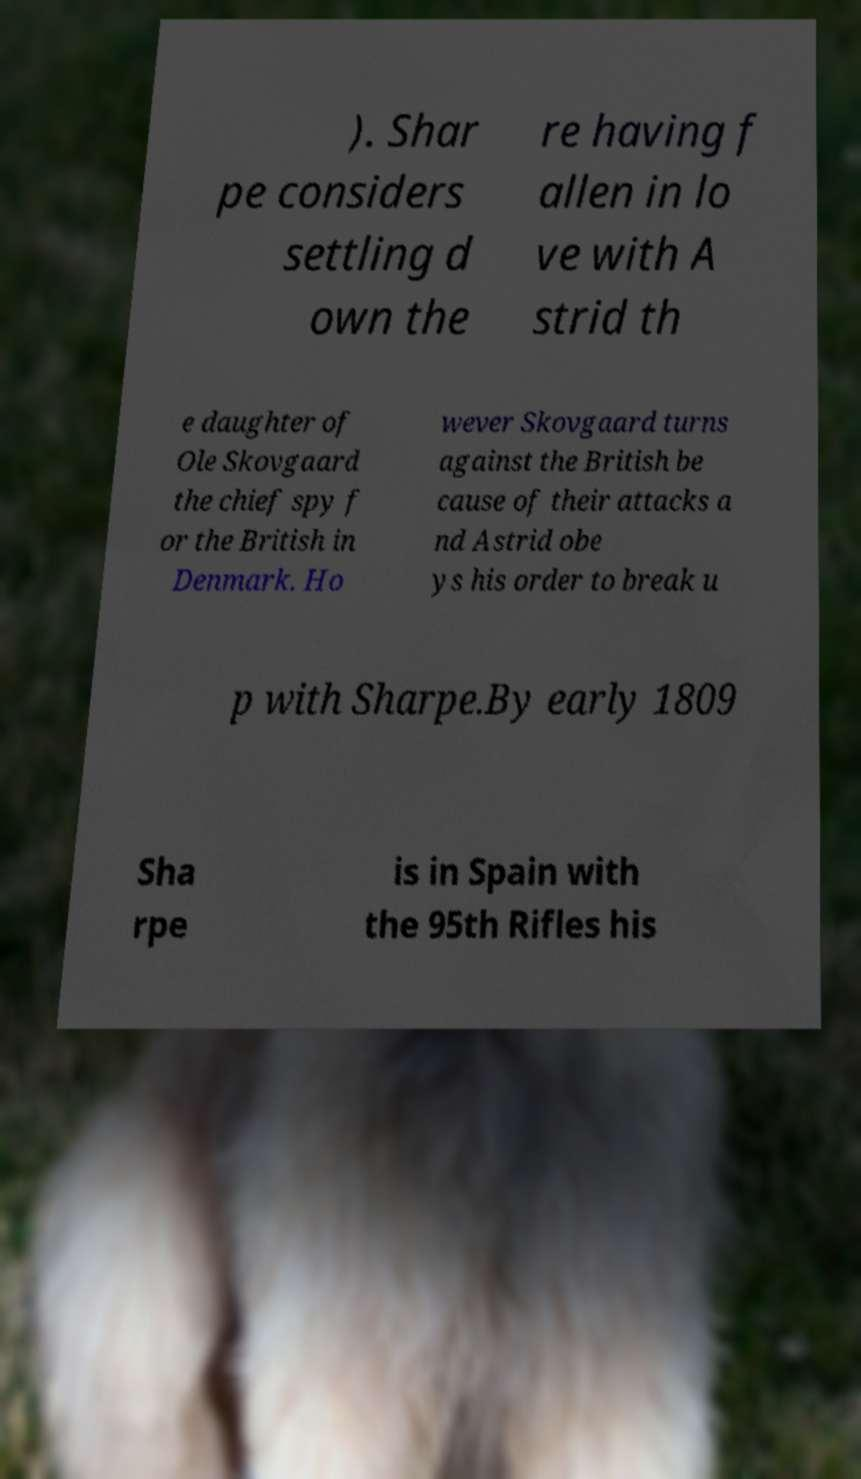Could you extract and type out the text from this image? ). Shar pe considers settling d own the re having f allen in lo ve with A strid th e daughter of Ole Skovgaard the chief spy f or the British in Denmark. Ho wever Skovgaard turns against the British be cause of their attacks a nd Astrid obe ys his order to break u p with Sharpe.By early 1809 Sha rpe is in Spain with the 95th Rifles his 